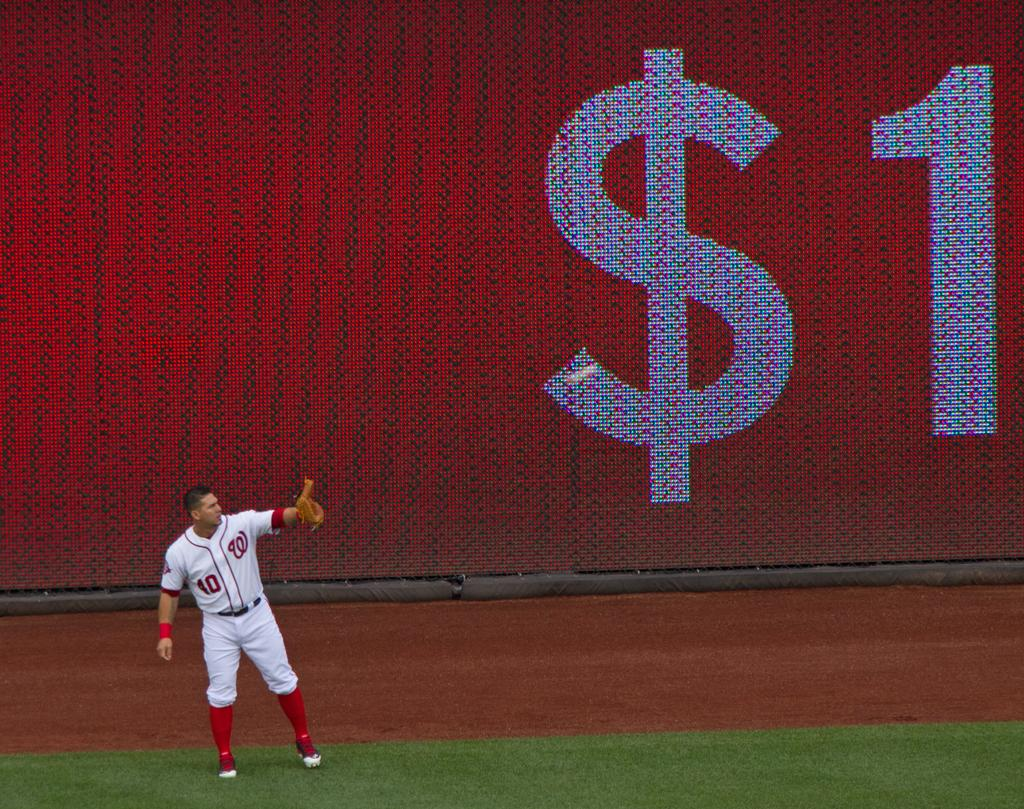<image>
Offer a succinct explanation of the picture presented. a man playing baseball with a W on his shirt 